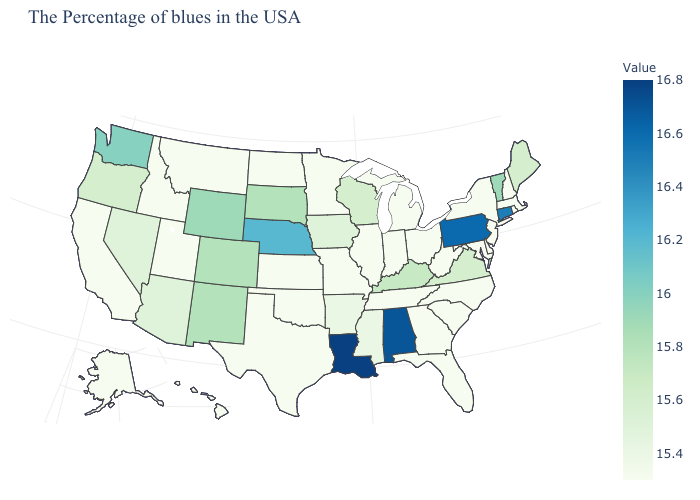Does North Carolina have the lowest value in the South?
Give a very brief answer. Yes. Does Delaware have the lowest value in the USA?
Short answer required. Yes. Does Delaware have the lowest value in the USA?
Answer briefly. Yes. Does Iowa have the lowest value in the USA?
Keep it brief. No. Is the legend a continuous bar?
Concise answer only. Yes. 